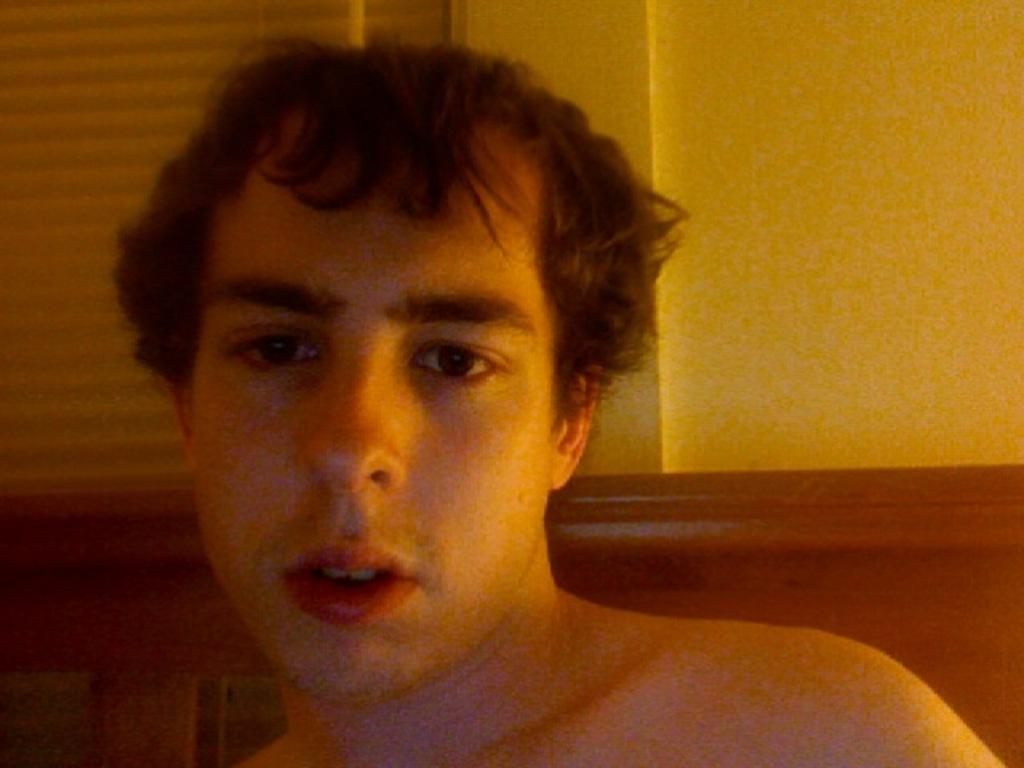Could you give a brief overview of what you see in this image? In this image we can see a person, there is a wooden object, wall and an object looks like a window blind in the background. 